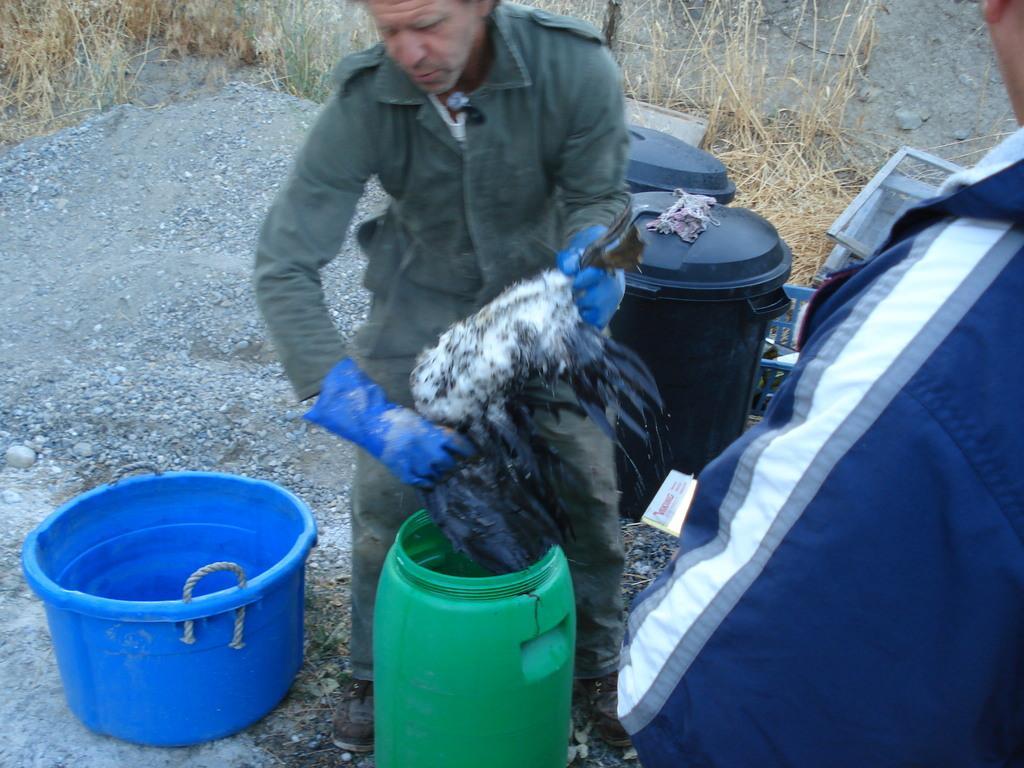Can you describe this image briefly? In this picture I can see two men among them a man is holding something in hands. Here I can see some plastic objects and a green color drum. In the background I can see grass. 